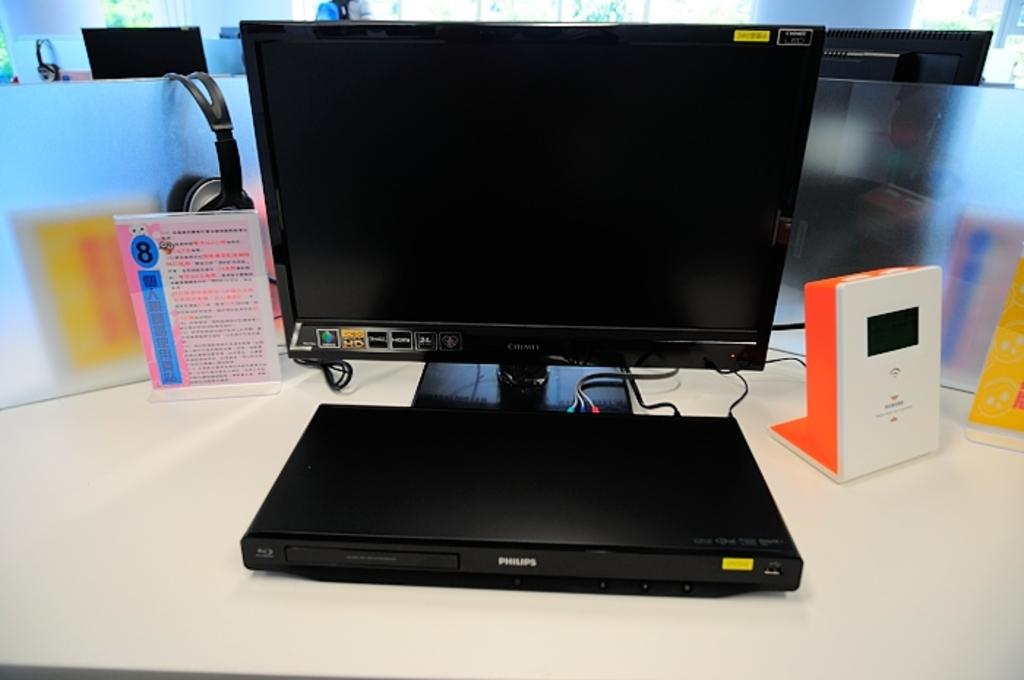<image>
Give a short and clear explanation of the subsequent image. A Phillips blue ray player with screen and a pink Asian number 8 sign on the left. 